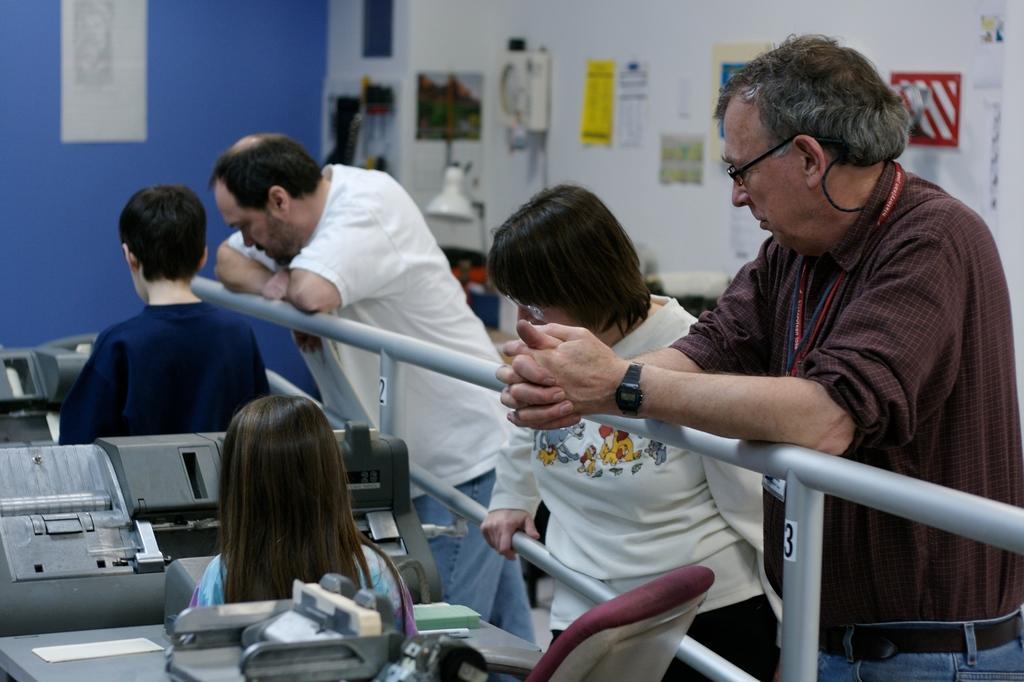Could you give a brief overview of what you see in this image? This picture is inside view of a room. We can see persons are standing. On the left side of the image a girl is sitting in-front of the printing machine. At the bottom of the image chair is there. At the top of the image we can see the wall, lamp, paper are present. In the middle of the image a rod is there. 